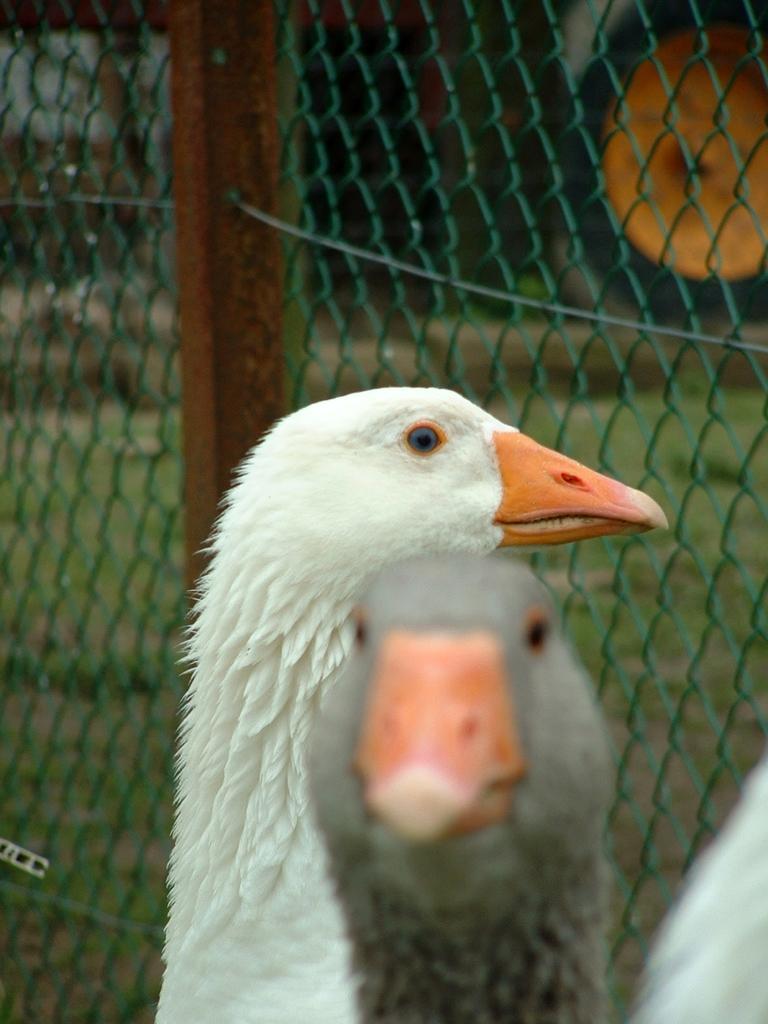Could you give a brief overview of what you see in this image? In this picture we can see a few birds. There is some fencing. Through this fencing, we can see some grass on the ground. We can see some objects in the background. 